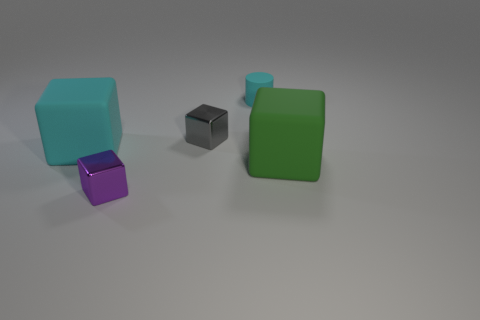There is a matte thing that is both to the right of the big cyan thing and on the left side of the big green block; what is its size?
Offer a very short reply. Small. The cyan thing that is left of the cylinder has what shape?
Offer a very short reply. Cube. Is the material of the big green block the same as the cyan object on the left side of the small matte cylinder?
Ensure brevity in your answer.  Yes. Does the tiny purple metallic thing have the same shape as the big cyan thing?
Provide a succinct answer. Yes. There is another tiny thing that is the same shape as the small purple object; what material is it?
Ensure brevity in your answer.  Metal. What color is the rubber object that is both in front of the gray cube and on the right side of the purple thing?
Offer a terse response. Green. What is the color of the cylinder?
Your response must be concise. Cyan. There is a thing that is the same color as the matte cylinder; what is its material?
Ensure brevity in your answer.  Rubber. Are there any brown matte objects that have the same shape as the big cyan object?
Make the answer very short. No. There is a rubber thing behind the cyan matte block; what size is it?
Your answer should be very brief. Small. 